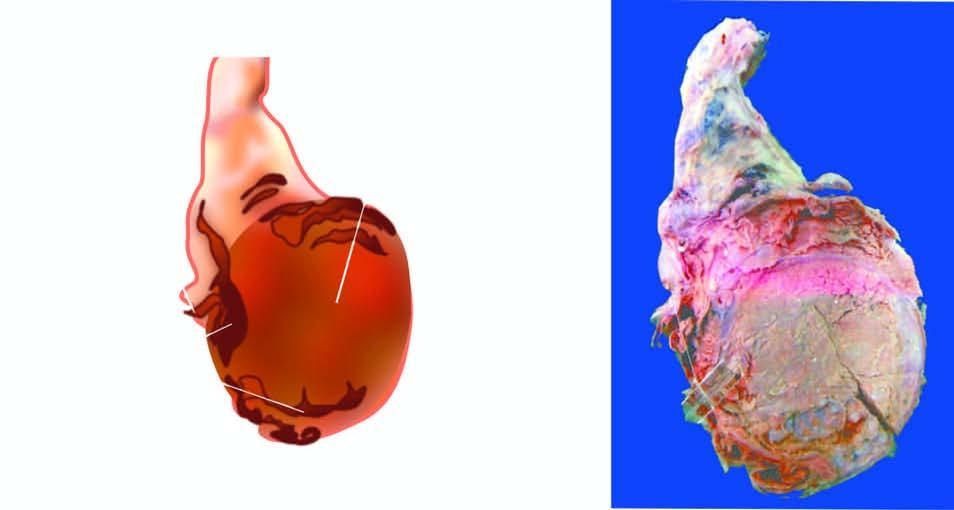how is the testis?
Answer the question using a single word or phrase. Enlarged and nodular distorting the testicular contour 